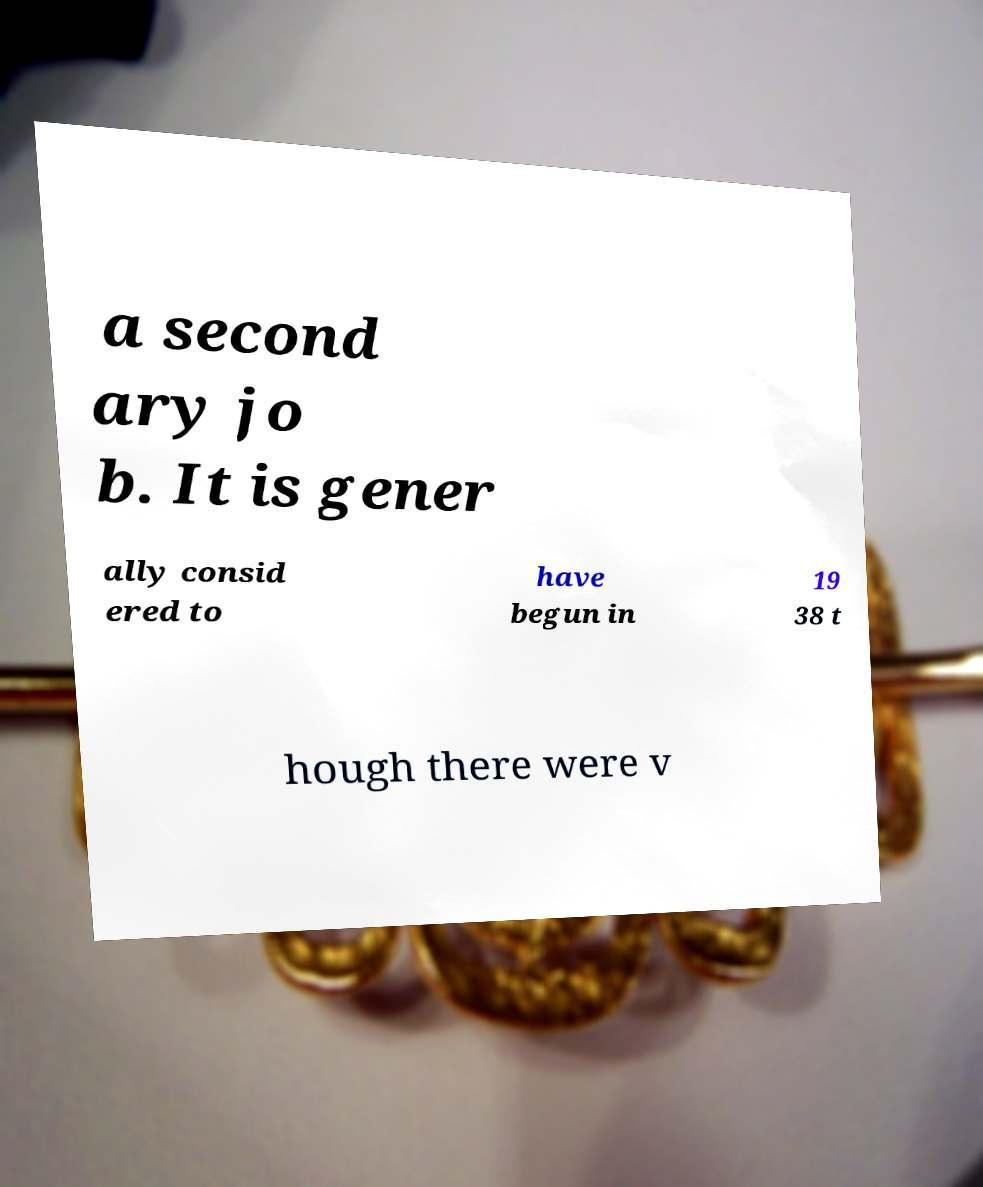Can you read and provide the text displayed in the image?This photo seems to have some interesting text. Can you extract and type it out for me? a second ary jo b. It is gener ally consid ered to have begun in 19 38 t hough there were v 